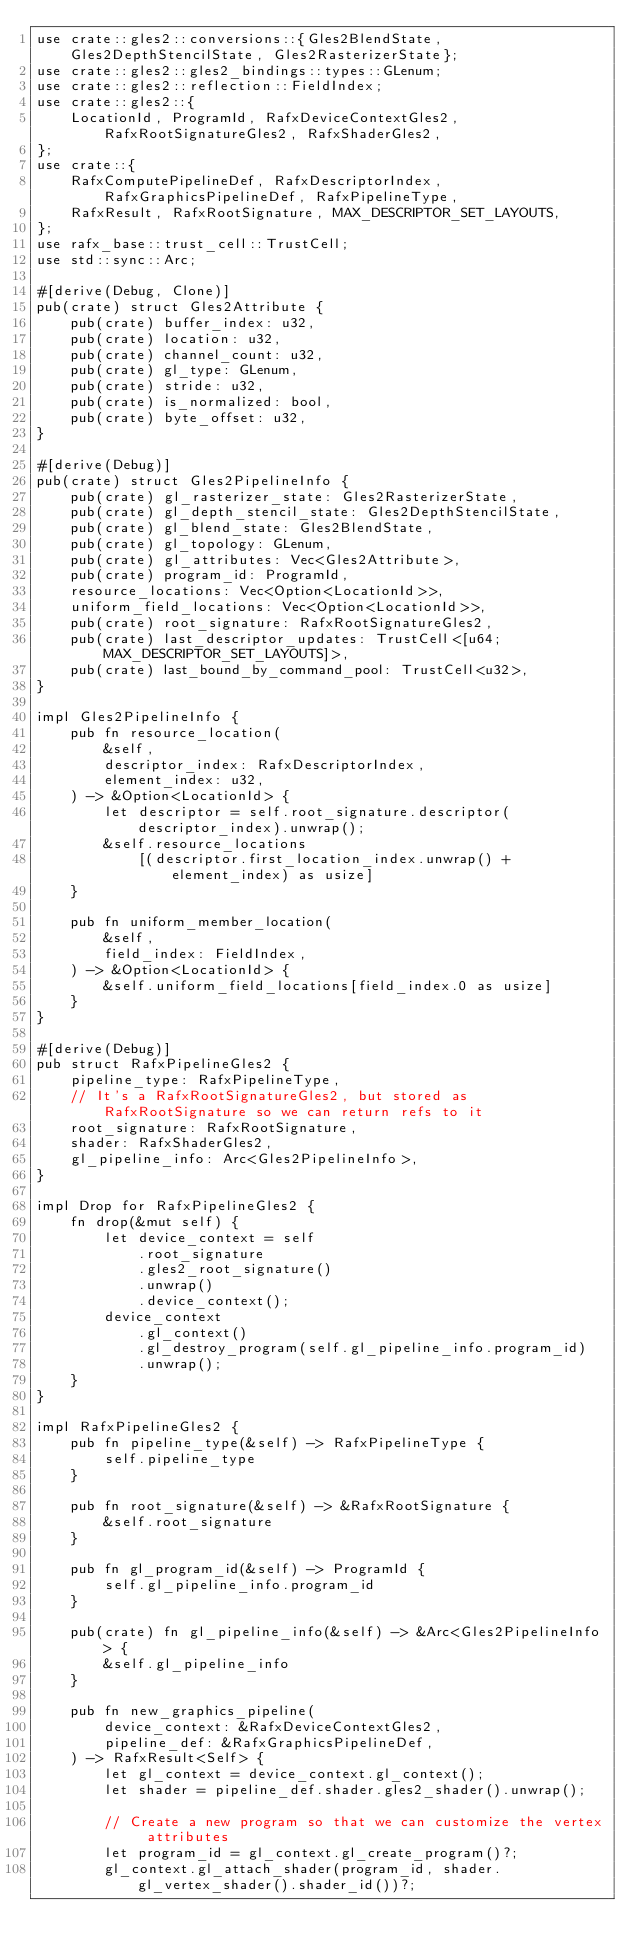Convert code to text. <code><loc_0><loc_0><loc_500><loc_500><_Rust_>use crate::gles2::conversions::{Gles2BlendState, Gles2DepthStencilState, Gles2RasterizerState};
use crate::gles2::gles2_bindings::types::GLenum;
use crate::gles2::reflection::FieldIndex;
use crate::gles2::{
    LocationId, ProgramId, RafxDeviceContextGles2, RafxRootSignatureGles2, RafxShaderGles2,
};
use crate::{
    RafxComputePipelineDef, RafxDescriptorIndex, RafxGraphicsPipelineDef, RafxPipelineType,
    RafxResult, RafxRootSignature, MAX_DESCRIPTOR_SET_LAYOUTS,
};
use rafx_base::trust_cell::TrustCell;
use std::sync::Arc;

#[derive(Debug, Clone)]
pub(crate) struct Gles2Attribute {
    pub(crate) buffer_index: u32,
    pub(crate) location: u32,
    pub(crate) channel_count: u32,
    pub(crate) gl_type: GLenum,
    pub(crate) stride: u32,
    pub(crate) is_normalized: bool,
    pub(crate) byte_offset: u32,
}

#[derive(Debug)]
pub(crate) struct Gles2PipelineInfo {
    pub(crate) gl_rasterizer_state: Gles2RasterizerState,
    pub(crate) gl_depth_stencil_state: Gles2DepthStencilState,
    pub(crate) gl_blend_state: Gles2BlendState,
    pub(crate) gl_topology: GLenum,
    pub(crate) gl_attributes: Vec<Gles2Attribute>,
    pub(crate) program_id: ProgramId,
    resource_locations: Vec<Option<LocationId>>,
    uniform_field_locations: Vec<Option<LocationId>>,
    pub(crate) root_signature: RafxRootSignatureGles2,
    pub(crate) last_descriptor_updates: TrustCell<[u64; MAX_DESCRIPTOR_SET_LAYOUTS]>,
    pub(crate) last_bound_by_command_pool: TrustCell<u32>,
}

impl Gles2PipelineInfo {
    pub fn resource_location(
        &self,
        descriptor_index: RafxDescriptorIndex,
        element_index: u32,
    ) -> &Option<LocationId> {
        let descriptor = self.root_signature.descriptor(descriptor_index).unwrap();
        &self.resource_locations
            [(descriptor.first_location_index.unwrap() + element_index) as usize]
    }

    pub fn uniform_member_location(
        &self,
        field_index: FieldIndex,
    ) -> &Option<LocationId> {
        &self.uniform_field_locations[field_index.0 as usize]
    }
}

#[derive(Debug)]
pub struct RafxPipelineGles2 {
    pipeline_type: RafxPipelineType,
    // It's a RafxRootSignatureGles2, but stored as RafxRootSignature so we can return refs to it
    root_signature: RafxRootSignature,
    shader: RafxShaderGles2,
    gl_pipeline_info: Arc<Gles2PipelineInfo>,
}

impl Drop for RafxPipelineGles2 {
    fn drop(&mut self) {
        let device_context = self
            .root_signature
            .gles2_root_signature()
            .unwrap()
            .device_context();
        device_context
            .gl_context()
            .gl_destroy_program(self.gl_pipeline_info.program_id)
            .unwrap();
    }
}

impl RafxPipelineGles2 {
    pub fn pipeline_type(&self) -> RafxPipelineType {
        self.pipeline_type
    }

    pub fn root_signature(&self) -> &RafxRootSignature {
        &self.root_signature
    }

    pub fn gl_program_id(&self) -> ProgramId {
        self.gl_pipeline_info.program_id
    }

    pub(crate) fn gl_pipeline_info(&self) -> &Arc<Gles2PipelineInfo> {
        &self.gl_pipeline_info
    }

    pub fn new_graphics_pipeline(
        device_context: &RafxDeviceContextGles2,
        pipeline_def: &RafxGraphicsPipelineDef,
    ) -> RafxResult<Self> {
        let gl_context = device_context.gl_context();
        let shader = pipeline_def.shader.gles2_shader().unwrap();

        // Create a new program so that we can customize the vertex attributes
        let program_id = gl_context.gl_create_program()?;
        gl_context.gl_attach_shader(program_id, shader.gl_vertex_shader().shader_id())?;</code> 